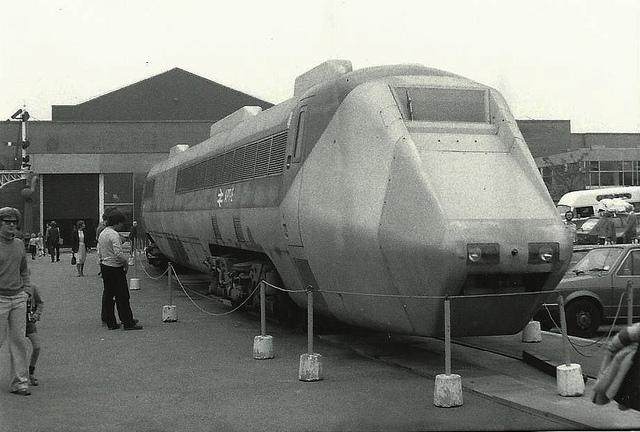Where is this train located?

Choices:
A) museum
B) bridge
C) country
D) tunnel museum 